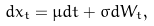<formula> <loc_0><loc_0><loc_500><loc_500>d x _ { t } = \mu d t + \sigma d W _ { t } ,</formula> 